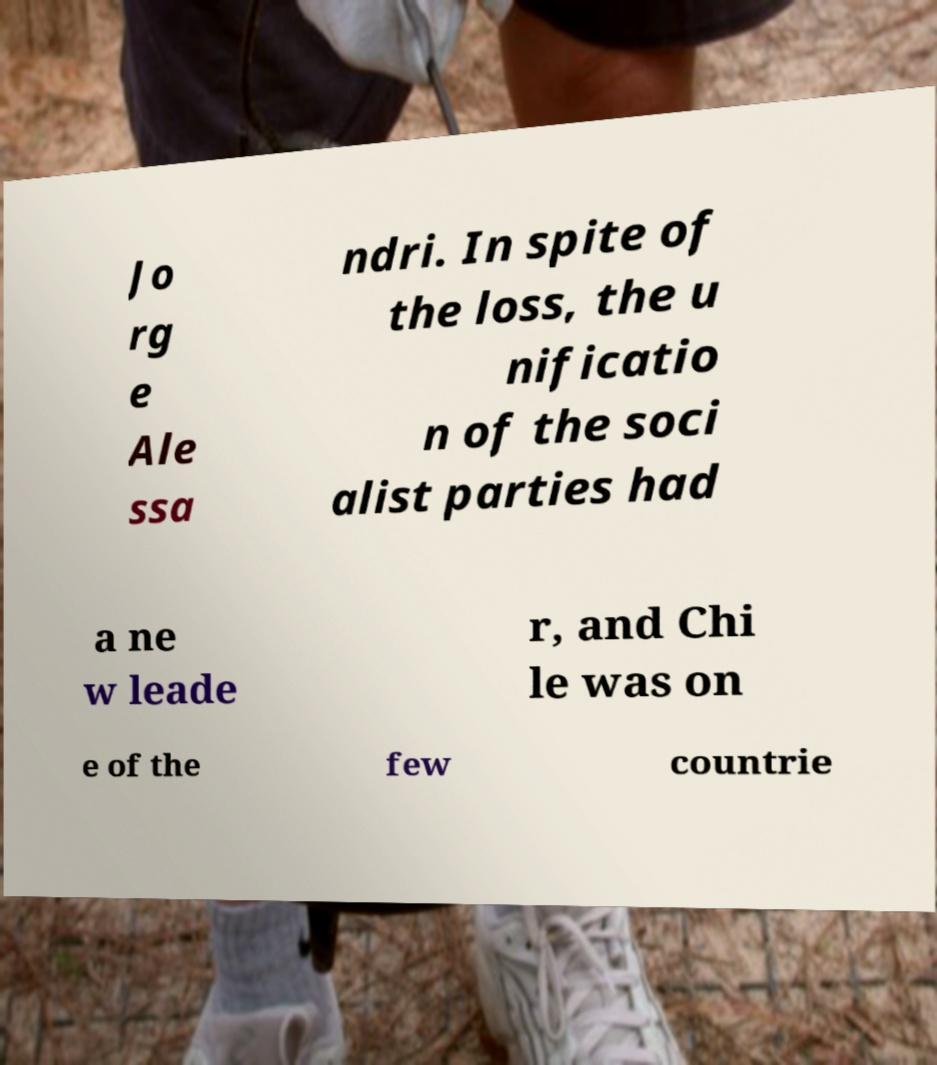Can you read and provide the text displayed in the image?This photo seems to have some interesting text. Can you extract and type it out for me? Jo rg e Ale ssa ndri. In spite of the loss, the u nificatio n of the soci alist parties had a ne w leade r, and Chi le was on e of the few countrie 